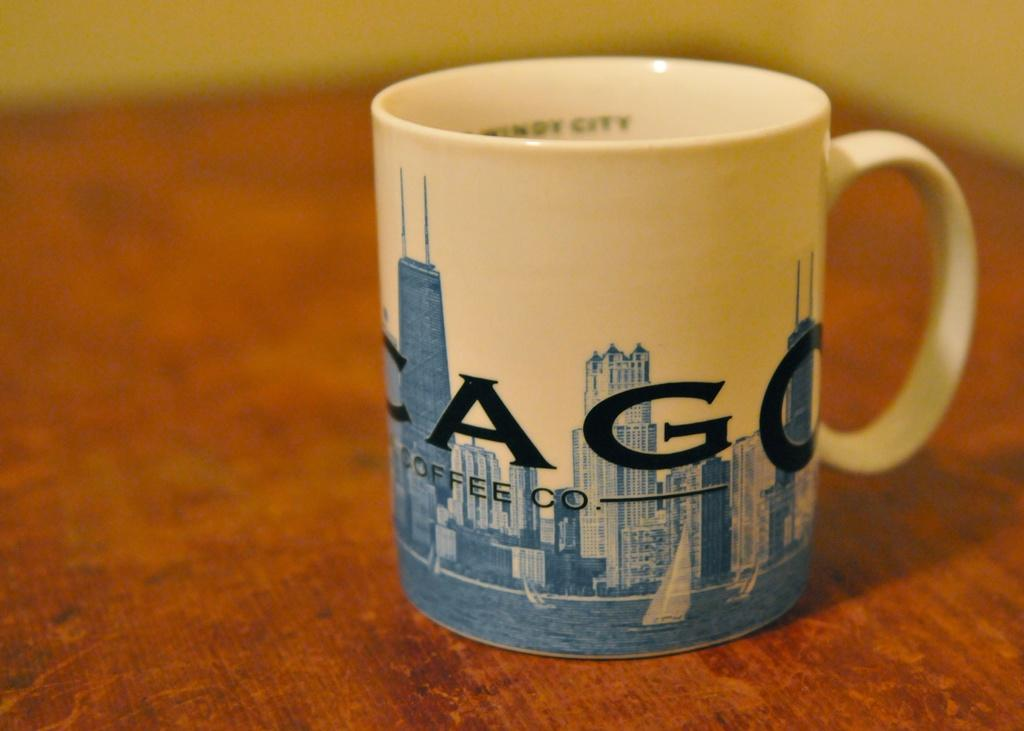Provide a one-sentence caption for the provided image. A mug on a table that says Cago coffee co. 